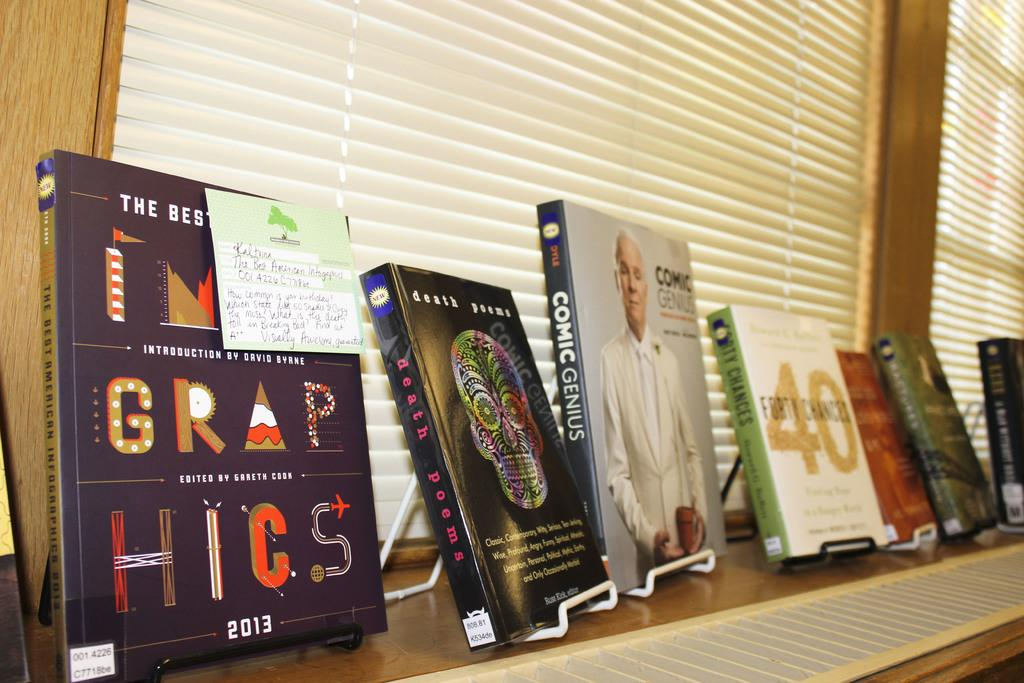<image>
Provide a brief description of the given image. Various books are displayed that include Grap Hicks and Comic Genius 